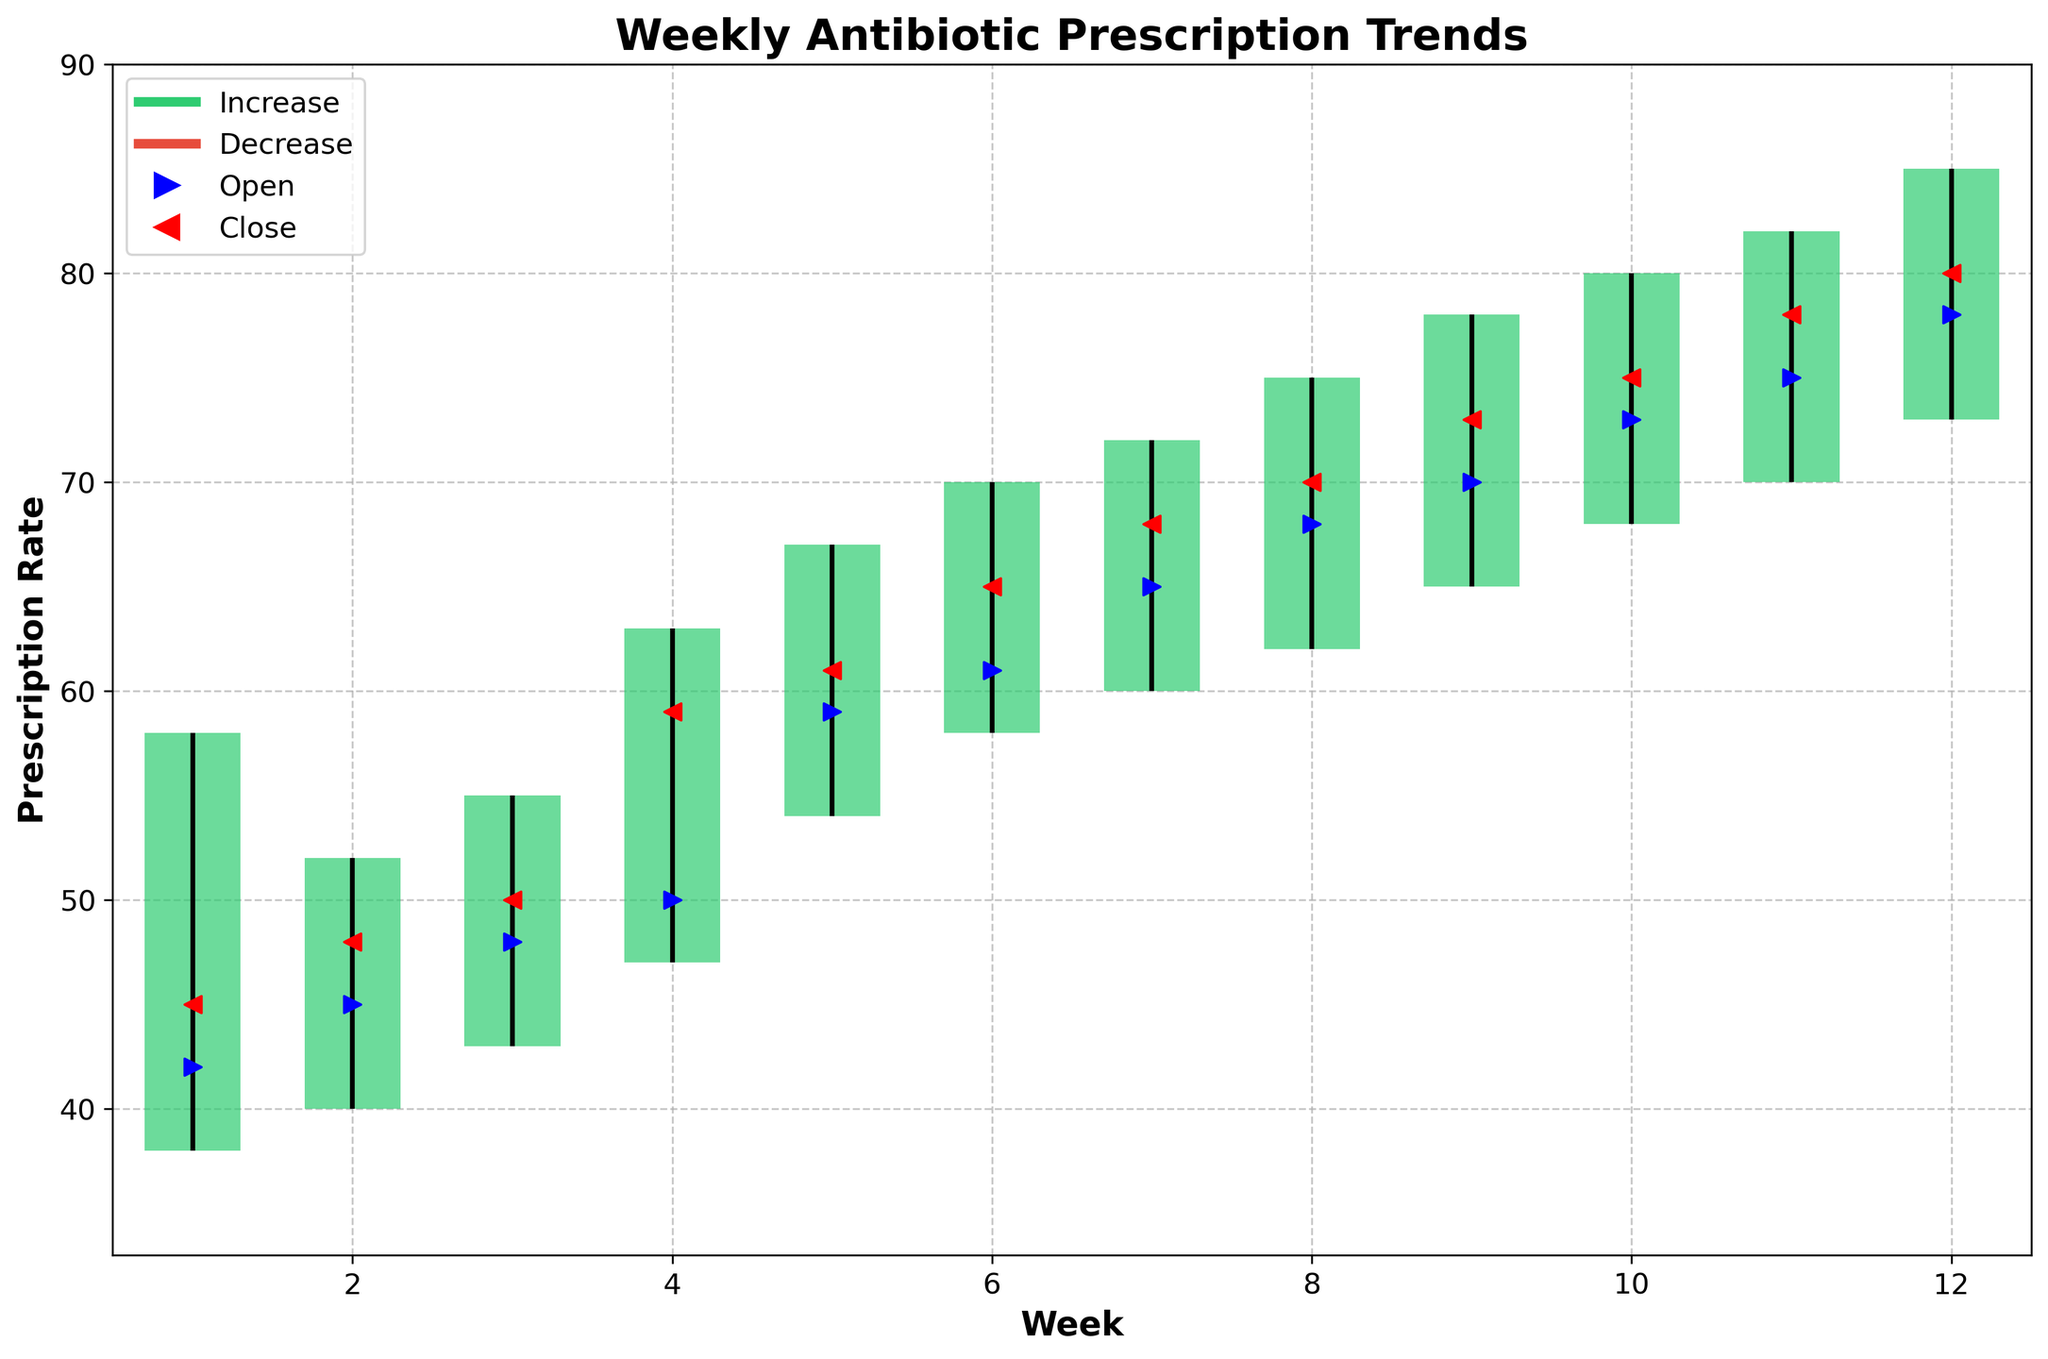What's the title of the chart? The title of the chart is displayed at the top in bold text. It helps to identify what the data represents.
Answer: Weekly Antibiotic Prescription Trends How many weeks are represented in the chart? The x-axis of the chart has ticks for each week from 1 through 12, which can be counted.
Answer: 12 What was the highest prescription rate recorded and during which week? The highest prescription rate is represented by the highest point on the y-axis within the chart. Locate the maximum value along the y-axis and note the corresponding week.
Answer: 85, Week 12 Which week had the lowest close prescription rate, and what was it? To find the lowest close prescription rate, check the red markers representing the close price and identify the week corresponding to the lowest marker.
Answer: Week 1, 45 Did the prescription rate increase or decrease from week 5 to week 6? Compare the close rate of week 5 with the open rate of week 6. A green bar indicates an increase, while a red bar indicates a decrease.
Answer: Increase Between which weeks did the largest range between the high and low prescription rates occur? Calculate the difference between the high and low prescription rates for each week. Note the week with the largest range.
Answer: Week 12 (Range: 85 - 73 = 12) How many weeks showed a decrease in prescription rates? Count the red bars in the chart, as these signify weeks where the close rate was lower than the open rate.
Answer: 0 Which week showed the smallest range between the high and low prescription rates, and what was the range? Calculate the difference between the high and low values for each week and identify the smallest range.
Answer: Week 2, Range: 52 - 40 = 12 What was the closing rate difference between week 8 and week 9? Subtract the closing prescription rate of week 8 from the closing prescription rate of week 9.
Answer: 3 (73 - 70) 